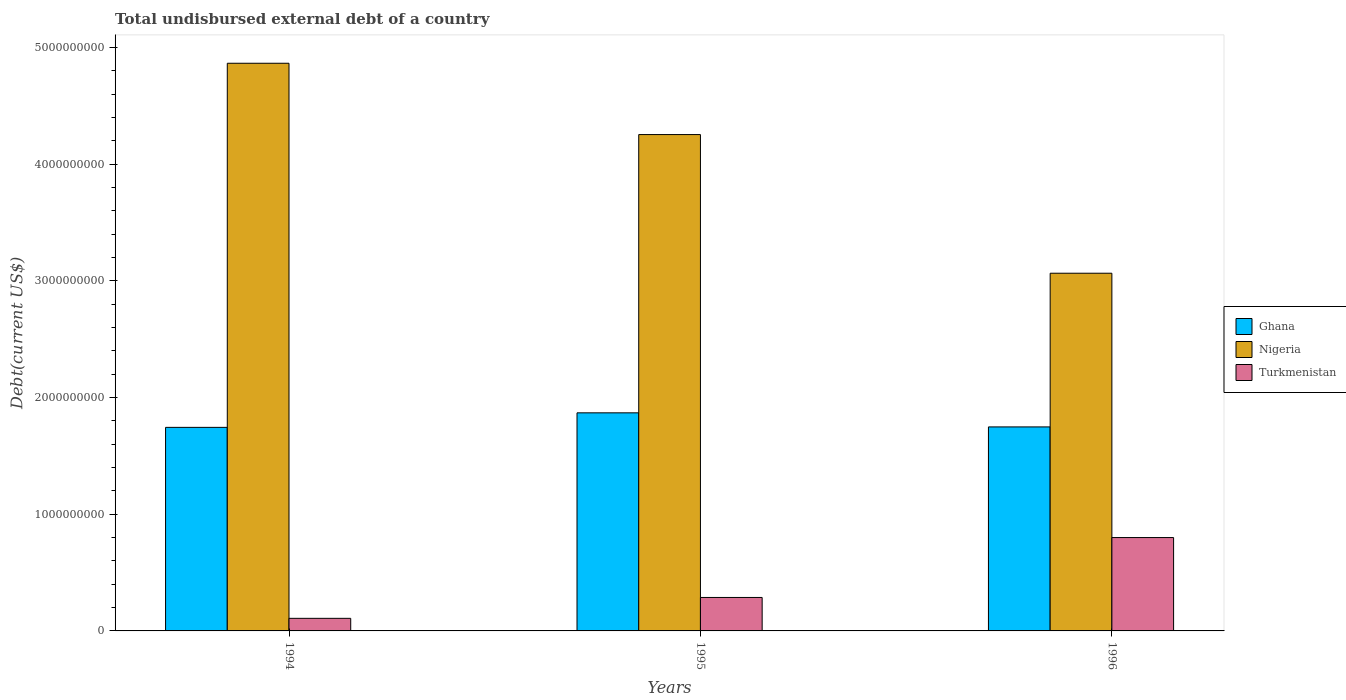How many different coloured bars are there?
Ensure brevity in your answer.  3. Are the number of bars per tick equal to the number of legend labels?
Provide a short and direct response. Yes. In how many cases, is the number of bars for a given year not equal to the number of legend labels?
Your answer should be very brief. 0. What is the total undisbursed external debt in Nigeria in 1996?
Ensure brevity in your answer.  3.06e+09. Across all years, what is the maximum total undisbursed external debt in Nigeria?
Ensure brevity in your answer.  4.86e+09. Across all years, what is the minimum total undisbursed external debt in Nigeria?
Your response must be concise. 3.06e+09. In which year was the total undisbursed external debt in Turkmenistan maximum?
Provide a short and direct response. 1996. What is the total total undisbursed external debt in Nigeria in the graph?
Give a very brief answer. 1.22e+1. What is the difference between the total undisbursed external debt in Turkmenistan in 1994 and that in 1996?
Provide a short and direct response. -6.92e+08. What is the difference between the total undisbursed external debt in Ghana in 1994 and the total undisbursed external debt in Turkmenistan in 1995?
Your answer should be very brief. 1.46e+09. What is the average total undisbursed external debt in Nigeria per year?
Ensure brevity in your answer.  4.06e+09. In the year 1994, what is the difference between the total undisbursed external debt in Ghana and total undisbursed external debt in Turkmenistan?
Make the answer very short. 1.64e+09. What is the ratio of the total undisbursed external debt in Ghana in 1994 to that in 1996?
Give a very brief answer. 1. Is the difference between the total undisbursed external debt in Ghana in 1994 and 1995 greater than the difference between the total undisbursed external debt in Turkmenistan in 1994 and 1995?
Your answer should be compact. Yes. What is the difference between the highest and the second highest total undisbursed external debt in Ghana?
Your answer should be compact. 1.21e+08. What is the difference between the highest and the lowest total undisbursed external debt in Nigeria?
Your answer should be very brief. 1.80e+09. In how many years, is the total undisbursed external debt in Nigeria greater than the average total undisbursed external debt in Nigeria taken over all years?
Provide a succinct answer. 2. Is the sum of the total undisbursed external debt in Nigeria in 1994 and 1996 greater than the maximum total undisbursed external debt in Turkmenistan across all years?
Your response must be concise. Yes. What does the 3rd bar from the left in 1996 represents?
Your response must be concise. Turkmenistan. What does the 1st bar from the right in 1994 represents?
Your answer should be compact. Turkmenistan. Is it the case that in every year, the sum of the total undisbursed external debt in Ghana and total undisbursed external debt in Turkmenistan is greater than the total undisbursed external debt in Nigeria?
Your answer should be very brief. No. How many bars are there?
Keep it short and to the point. 9. What is the difference between two consecutive major ticks on the Y-axis?
Give a very brief answer. 1.00e+09. Are the values on the major ticks of Y-axis written in scientific E-notation?
Provide a succinct answer. No. Does the graph contain any zero values?
Provide a short and direct response. No. Where does the legend appear in the graph?
Offer a terse response. Center right. What is the title of the graph?
Your answer should be compact. Total undisbursed external debt of a country. What is the label or title of the X-axis?
Offer a terse response. Years. What is the label or title of the Y-axis?
Your response must be concise. Debt(current US$). What is the Debt(current US$) in Ghana in 1994?
Your answer should be very brief. 1.74e+09. What is the Debt(current US$) in Nigeria in 1994?
Offer a very short reply. 4.86e+09. What is the Debt(current US$) of Turkmenistan in 1994?
Your response must be concise. 1.08e+08. What is the Debt(current US$) in Ghana in 1995?
Your response must be concise. 1.87e+09. What is the Debt(current US$) of Nigeria in 1995?
Provide a succinct answer. 4.25e+09. What is the Debt(current US$) in Turkmenistan in 1995?
Keep it short and to the point. 2.87e+08. What is the Debt(current US$) in Ghana in 1996?
Provide a short and direct response. 1.75e+09. What is the Debt(current US$) of Nigeria in 1996?
Keep it short and to the point. 3.06e+09. What is the Debt(current US$) in Turkmenistan in 1996?
Provide a short and direct response. 8.00e+08. Across all years, what is the maximum Debt(current US$) in Ghana?
Provide a short and direct response. 1.87e+09. Across all years, what is the maximum Debt(current US$) in Nigeria?
Your answer should be compact. 4.86e+09. Across all years, what is the maximum Debt(current US$) in Turkmenistan?
Provide a short and direct response. 8.00e+08. Across all years, what is the minimum Debt(current US$) in Ghana?
Provide a short and direct response. 1.74e+09. Across all years, what is the minimum Debt(current US$) of Nigeria?
Provide a succinct answer. 3.06e+09. Across all years, what is the minimum Debt(current US$) of Turkmenistan?
Provide a succinct answer. 1.08e+08. What is the total Debt(current US$) of Ghana in the graph?
Provide a succinct answer. 5.36e+09. What is the total Debt(current US$) of Nigeria in the graph?
Your response must be concise. 1.22e+1. What is the total Debt(current US$) in Turkmenistan in the graph?
Your response must be concise. 1.19e+09. What is the difference between the Debt(current US$) in Ghana in 1994 and that in 1995?
Your response must be concise. -1.24e+08. What is the difference between the Debt(current US$) of Nigeria in 1994 and that in 1995?
Give a very brief answer. 6.11e+08. What is the difference between the Debt(current US$) in Turkmenistan in 1994 and that in 1995?
Provide a succinct answer. -1.79e+08. What is the difference between the Debt(current US$) in Ghana in 1994 and that in 1996?
Your answer should be very brief. -3.93e+06. What is the difference between the Debt(current US$) of Nigeria in 1994 and that in 1996?
Ensure brevity in your answer.  1.80e+09. What is the difference between the Debt(current US$) in Turkmenistan in 1994 and that in 1996?
Provide a short and direct response. -6.92e+08. What is the difference between the Debt(current US$) in Ghana in 1995 and that in 1996?
Offer a terse response. 1.21e+08. What is the difference between the Debt(current US$) in Nigeria in 1995 and that in 1996?
Offer a very short reply. 1.19e+09. What is the difference between the Debt(current US$) of Turkmenistan in 1995 and that in 1996?
Give a very brief answer. -5.13e+08. What is the difference between the Debt(current US$) of Ghana in 1994 and the Debt(current US$) of Nigeria in 1995?
Provide a succinct answer. -2.51e+09. What is the difference between the Debt(current US$) in Ghana in 1994 and the Debt(current US$) in Turkmenistan in 1995?
Your answer should be compact. 1.46e+09. What is the difference between the Debt(current US$) in Nigeria in 1994 and the Debt(current US$) in Turkmenistan in 1995?
Ensure brevity in your answer.  4.58e+09. What is the difference between the Debt(current US$) of Ghana in 1994 and the Debt(current US$) of Nigeria in 1996?
Ensure brevity in your answer.  -1.32e+09. What is the difference between the Debt(current US$) in Ghana in 1994 and the Debt(current US$) in Turkmenistan in 1996?
Keep it short and to the point. 9.44e+08. What is the difference between the Debt(current US$) in Nigeria in 1994 and the Debt(current US$) in Turkmenistan in 1996?
Offer a terse response. 4.06e+09. What is the difference between the Debt(current US$) of Ghana in 1995 and the Debt(current US$) of Nigeria in 1996?
Keep it short and to the point. -1.20e+09. What is the difference between the Debt(current US$) of Ghana in 1995 and the Debt(current US$) of Turkmenistan in 1996?
Your answer should be very brief. 1.07e+09. What is the difference between the Debt(current US$) in Nigeria in 1995 and the Debt(current US$) in Turkmenistan in 1996?
Offer a very short reply. 3.45e+09. What is the average Debt(current US$) of Ghana per year?
Ensure brevity in your answer.  1.79e+09. What is the average Debt(current US$) in Nigeria per year?
Your answer should be compact. 4.06e+09. What is the average Debt(current US$) in Turkmenistan per year?
Your answer should be very brief. 3.98e+08. In the year 1994, what is the difference between the Debt(current US$) of Ghana and Debt(current US$) of Nigeria?
Your response must be concise. -3.12e+09. In the year 1994, what is the difference between the Debt(current US$) in Ghana and Debt(current US$) in Turkmenistan?
Make the answer very short. 1.64e+09. In the year 1994, what is the difference between the Debt(current US$) of Nigeria and Debt(current US$) of Turkmenistan?
Your response must be concise. 4.76e+09. In the year 1995, what is the difference between the Debt(current US$) of Ghana and Debt(current US$) of Nigeria?
Make the answer very short. -2.38e+09. In the year 1995, what is the difference between the Debt(current US$) of Ghana and Debt(current US$) of Turkmenistan?
Ensure brevity in your answer.  1.58e+09. In the year 1995, what is the difference between the Debt(current US$) of Nigeria and Debt(current US$) of Turkmenistan?
Offer a terse response. 3.97e+09. In the year 1996, what is the difference between the Debt(current US$) of Ghana and Debt(current US$) of Nigeria?
Make the answer very short. -1.32e+09. In the year 1996, what is the difference between the Debt(current US$) in Ghana and Debt(current US$) in Turkmenistan?
Make the answer very short. 9.48e+08. In the year 1996, what is the difference between the Debt(current US$) of Nigeria and Debt(current US$) of Turkmenistan?
Ensure brevity in your answer.  2.26e+09. What is the ratio of the Debt(current US$) in Ghana in 1994 to that in 1995?
Offer a terse response. 0.93. What is the ratio of the Debt(current US$) of Nigeria in 1994 to that in 1995?
Offer a terse response. 1.14. What is the ratio of the Debt(current US$) in Turkmenistan in 1994 to that in 1995?
Your answer should be very brief. 0.38. What is the ratio of the Debt(current US$) in Nigeria in 1994 to that in 1996?
Provide a succinct answer. 1.59. What is the ratio of the Debt(current US$) in Turkmenistan in 1994 to that in 1996?
Ensure brevity in your answer.  0.13. What is the ratio of the Debt(current US$) in Ghana in 1995 to that in 1996?
Offer a terse response. 1.07. What is the ratio of the Debt(current US$) in Nigeria in 1995 to that in 1996?
Give a very brief answer. 1.39. What is the ratio of the Debt(current US$) of Turkmenistan in 1995 to that in 1996?
Your answer should be compact. 0.36. What is the difference between the highest and the second highest Debt(current US$) of Ghana?
Offer a very short reply. 1.21e+08. What is the difference between the highest and the second highest Debt(current US$) of Nigeria?
Your answer should be compact. 6.11e+08. What is the difference between the highest and the second highest Debt(current US$) of Turkmenistan?
Make the answer very short. 5.13e+08. What is the difference between the highest and the lowest Debt(current US$) of Ghana?
Give a very brief answer. 1.24e+08. What is the difference between the highest and the lowest Debt(current US$) of Nigeria?
Ensure brevity in your answer.  1.80e+09. What is the difference between the highest and the lowest Debt(current US$) of Turkmenistan?
Ensure brevity in your answer.  6.92e+08. 